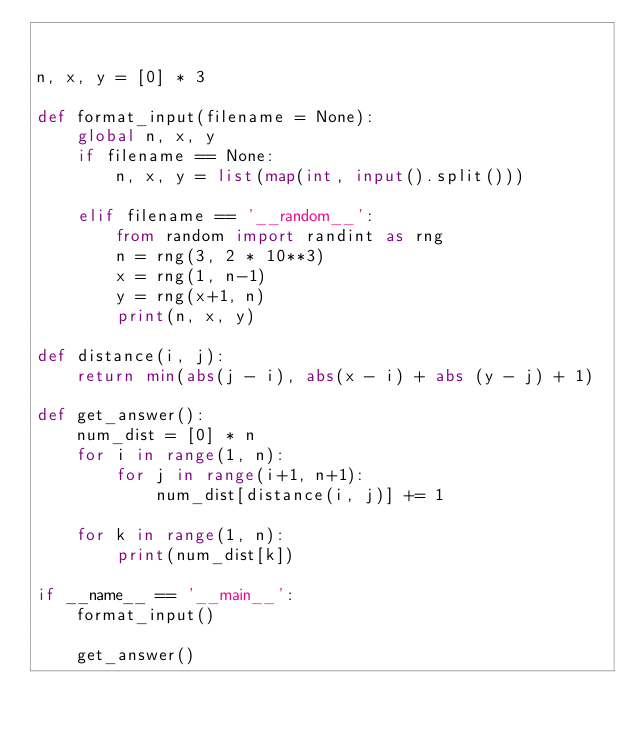<code> <loc_0><loc_0><loc_500><loc_500><_Python_>

n, x, y = [0] * 3

def format_input(filename = None):
	global n, x, y
	if filename == None:
		n, x, y = list(map(int, input().split()))

	elif filename == '__random__':
		from random import randint as rng
		n = rng(3, 2 * 10**3)
		x = rng(1, n-1)
		y = rng(x+1, n)
		print(n, x, y)

def distance(i, j):
	return min(abs(j - i), abs(x - i) + abs (y - j) + 1)

def get_answer():
	num_dist = [0] * n
	for i in range(1, n):
		for j in range(i+1, n+1):
			num_dist[distance(i, j)] += 1

	for k in range(1, n):
		print(num_dist[k])

if __name__ == '__main__':
	format_input()

	get_answer()
</code> 